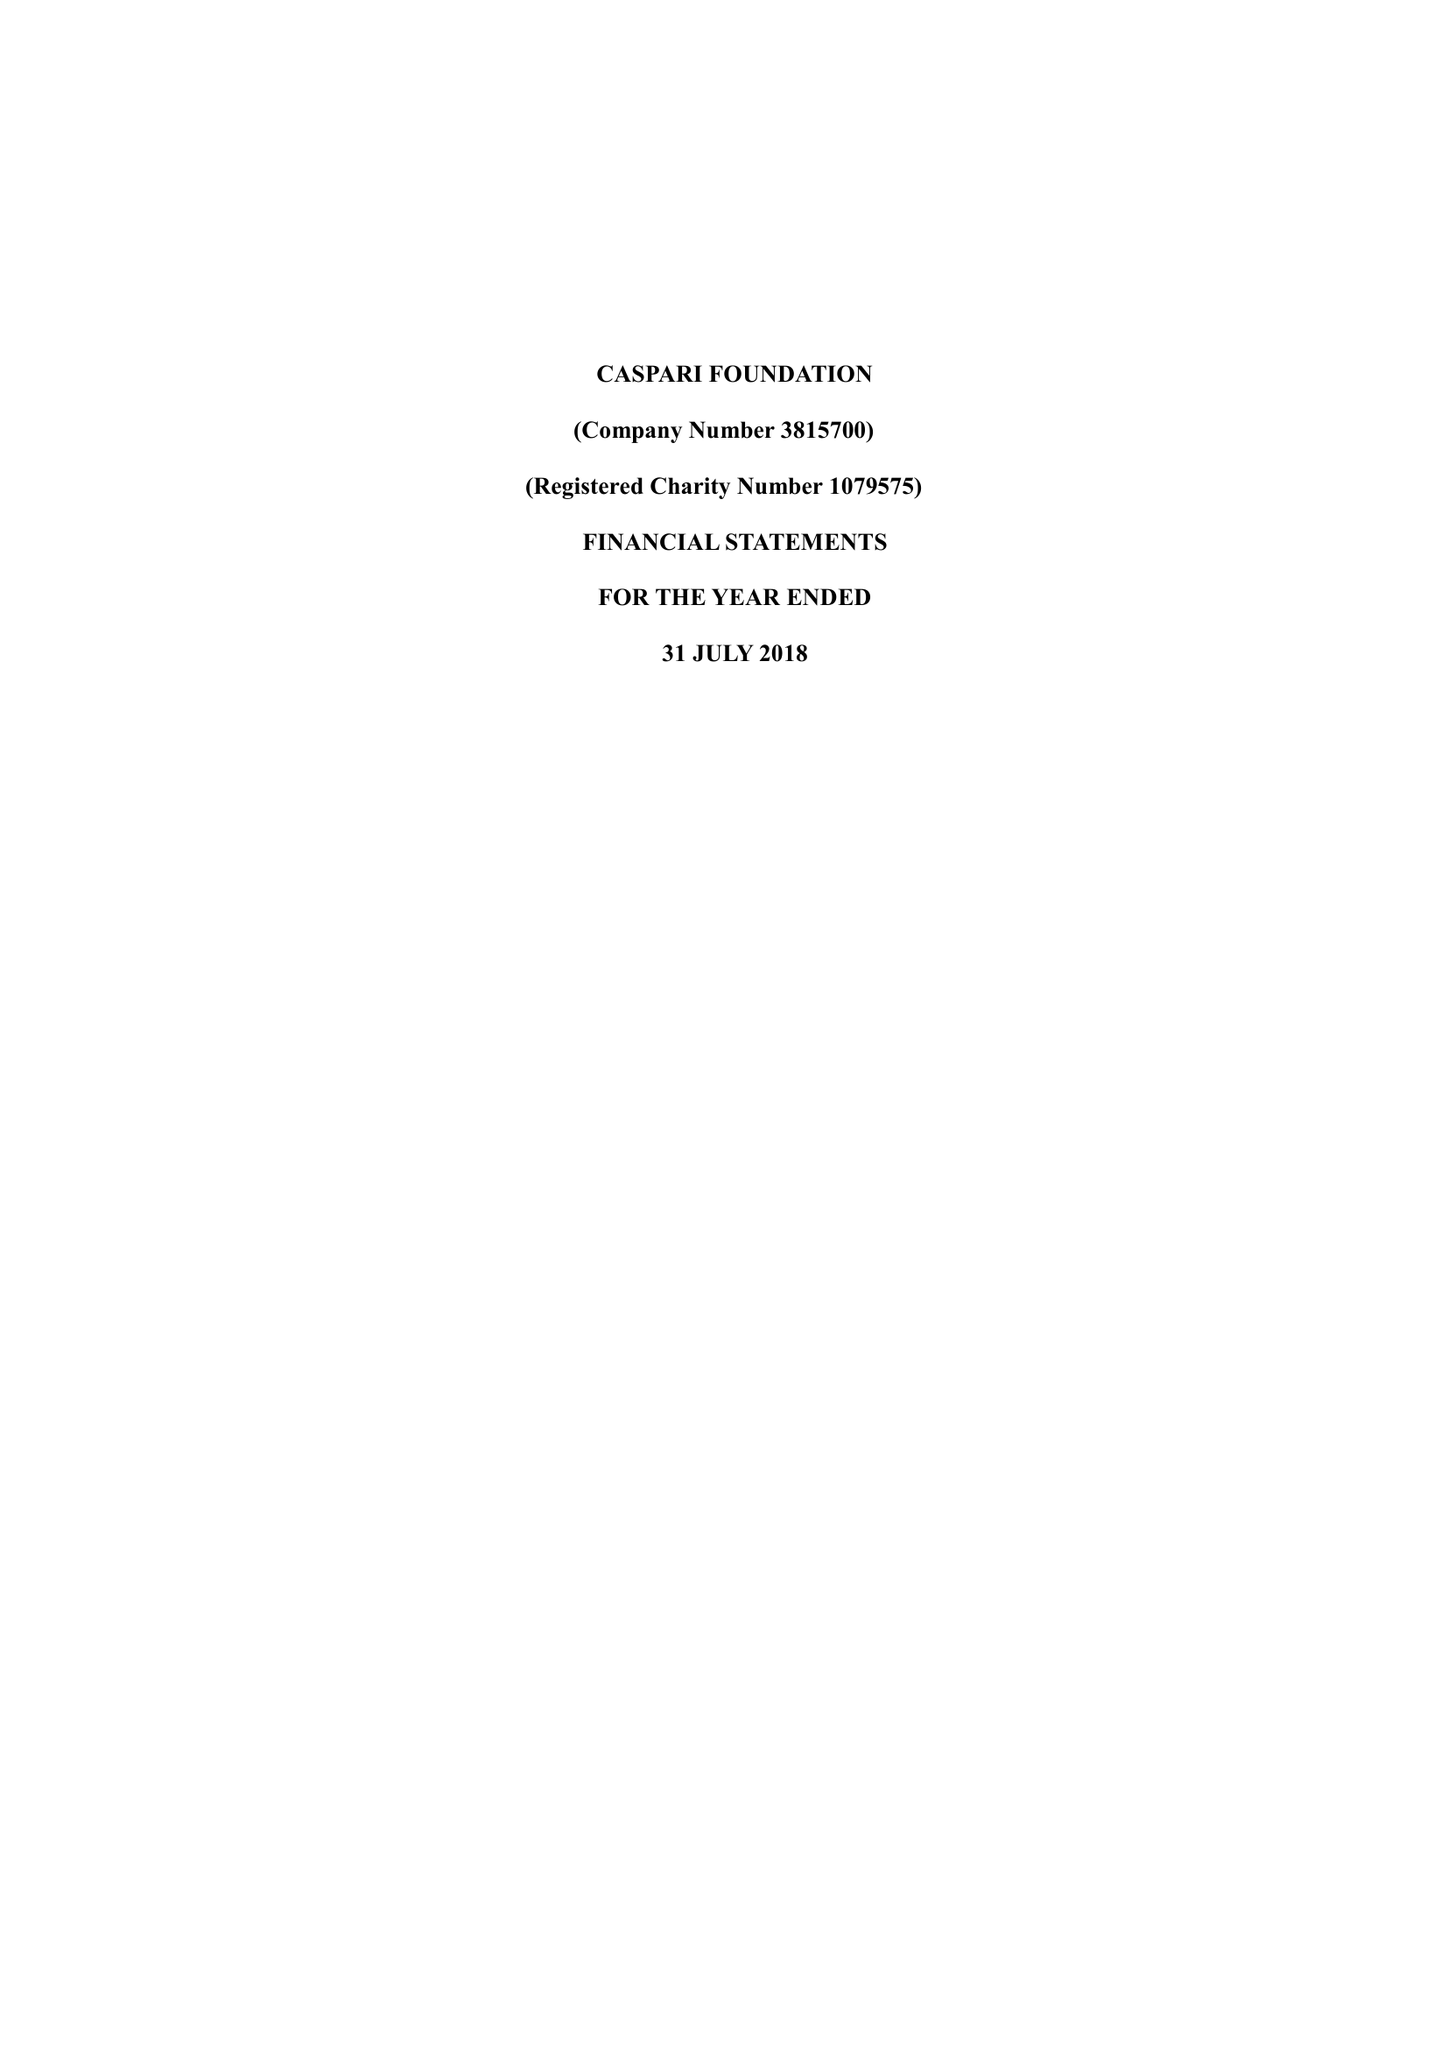What is the value for the charity_number?
Answer the question using a single word or phrase. 1079575 